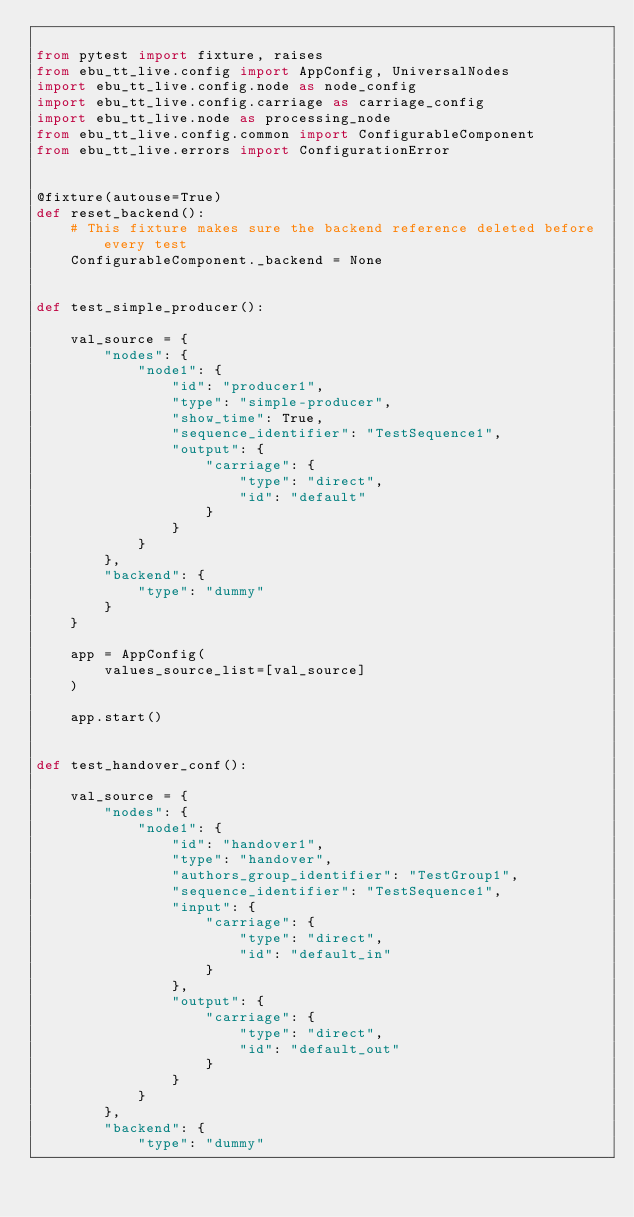<code> <loc_0><loc_0><loc_500><loc_500><_Python_>
from pytest import fixture, raises
from ebu_tt_live.config import AppConfig, UniversalNodes
import ebu_tt_live.config.node as node_config
import ebu_tt_live.config.carriage as carriage_config
import ebu_tt_live.node as processing_node
from ebu_tt_live.config.common import ConfigurableComponent
from ebu_tt_live.errors import ConfigurationError


@fixture(autouse=True)
def reset_backend():
    # This fixture makes sure the backend reference deleted before every test
    ConfigurableComponent._backend = None


def test_simple_producer():

    val_source = {
        "nodes": {
            "node1": {
                "id": "producer1",
                "type": "simple-producer",
                "show_time": True,
                "sequence_identifier": "TestSequence1",
                "output": {
                    "carriage": {
                        "type": "direct",
                        "id": "default"
                    }
                }
            }
        },
        "backend": {
            "type": "dummy"
        }
    }

    app = AppConfig(
        values_source_list=[val_source]
    )

    app.start()


def test_handover_conf():

    val_source = {
        "nodes": {
            "node1": {
                "id": "handover1",
                "type": "handover",
                "authors_group_identifier": "TestGroup1",
                "sequence_identifier": "TestSequence1",
                "input": {
                    "carriage": {
                        "type": "direct",
                        "id": "default_in"
                    }
                },
                "output": {
                    "carriage": {
                        "type": "direct",
                        "id": "default_out"
                    }
                }
            }
        },
        "backend": {
            "type": "dummy"</code> 